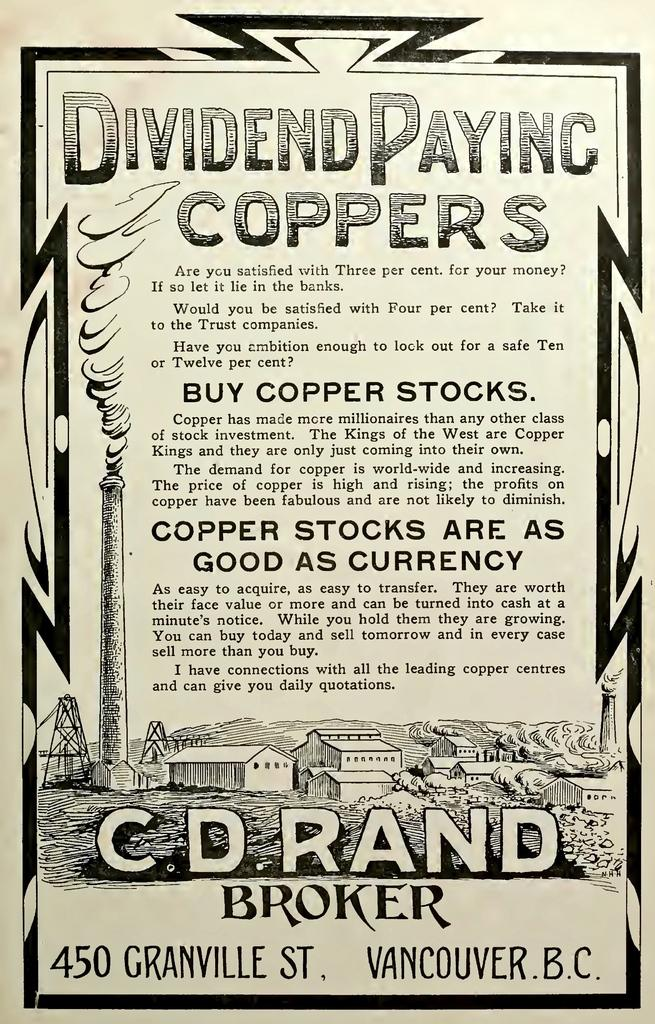<image>
Offer a succinct explanation of the picture presented. A black and white poster that titles Dividend Paying Coppers 